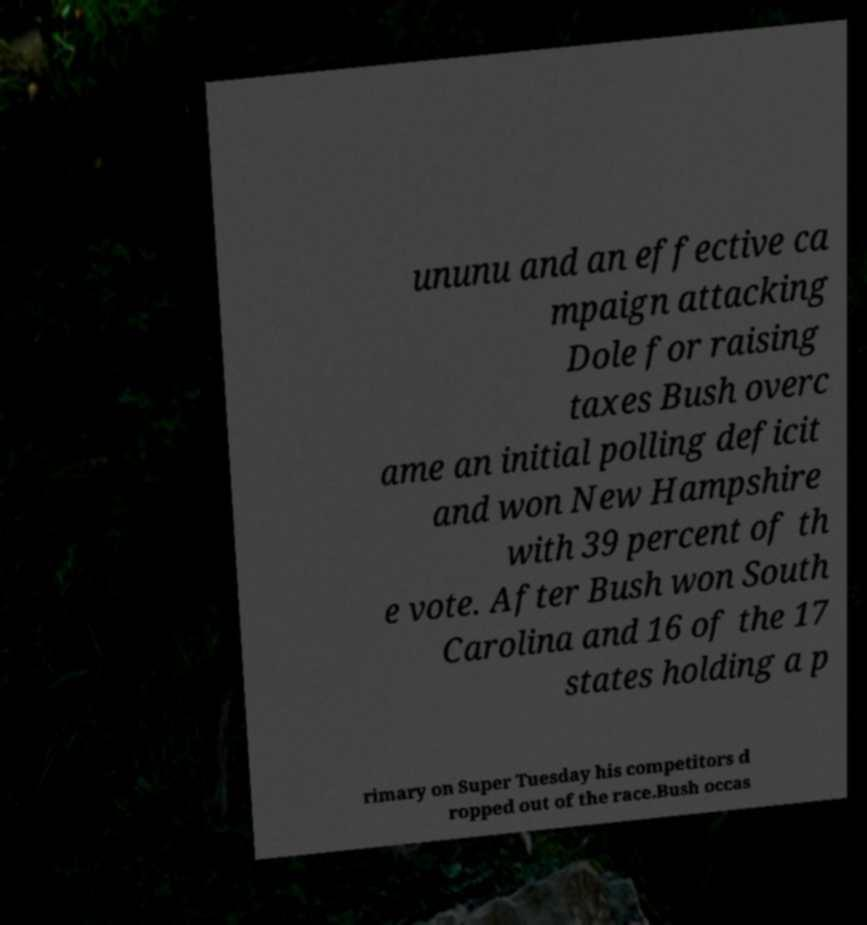Please read and relay the text visible in this image. What does it say? ununu and an effective ca mpaign attacking Dole for raising taxes Bush overc ame an initial polling deficit and won New Hampshire with 39 percent of th e vote. After Bush won South Carolina and 16 of the 17 states holding a p rimary on Super Tuesday his competitors d ropped out of the race.Bush occas 